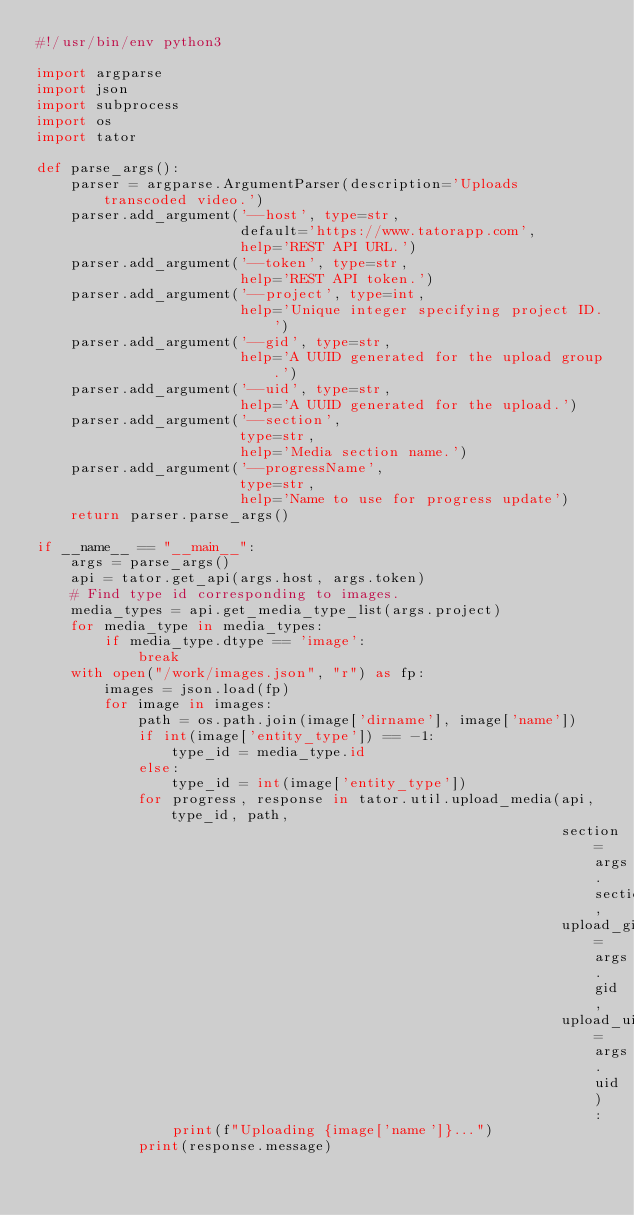<code> <loc_0><loc_0><loc_500><loc_500><_Python_>#!/usr/bin/env python3

import argparse
import json
import subprocess
import os
import tator

def parse_args():
    parser = argparse.ArgumentParser(description='Uploads transcoded video.')
    parser.add_argument('--host', type=str,
                        default='https://www.tatorapp.com',
                        help='REST API URL.')
    parser.add_argument('--token', type=str,
                        help='REST API token.')
    parser.add_argument('--project', type=int,
                        help='Unique integer specifying project ID.')
    parser.add_argument('--gid', type=str,
                        help='A UUID generated for the upload group.')
    parser.add_argument('--uid', type=str,
                        help='A UUID generated for the upload.')
    parser.add_argument('--section',
                        type=str,
                        help='Media section name.')
    parser.add_argument('--progressName',
                        type=str,
                        help='Name to use for progress update')
    return parser.parse_args()

if __name__ == "__main__":
    args = parse_args()
    api = tator.get_api(args.host, args.token)
    # Find type id corresponding to images.
    media_types = api.get_media_type_list(args.project)
    for media_type in media_types:
        if media_type.dtype == 'image':
            break
    with open("/work/images.json", "r") as fp:
        images = json.load(fp)
        for image in images:
            path = os.path.join(image['dirname'], image['name'])
            if int(image['entity_type']) == -1:
                type_id = media_type.id
            else:
                type_id = int(image['entity_type'])
            for progress, response in tator.util.upload_media(api, type_id, path,
                                                              section=args.section,
                                                              upload_gid=args.gid,
                                                              upload_uid=args.uid):
                print(f"Uploading {image['name']}...")
            print(response.message)
</code> 